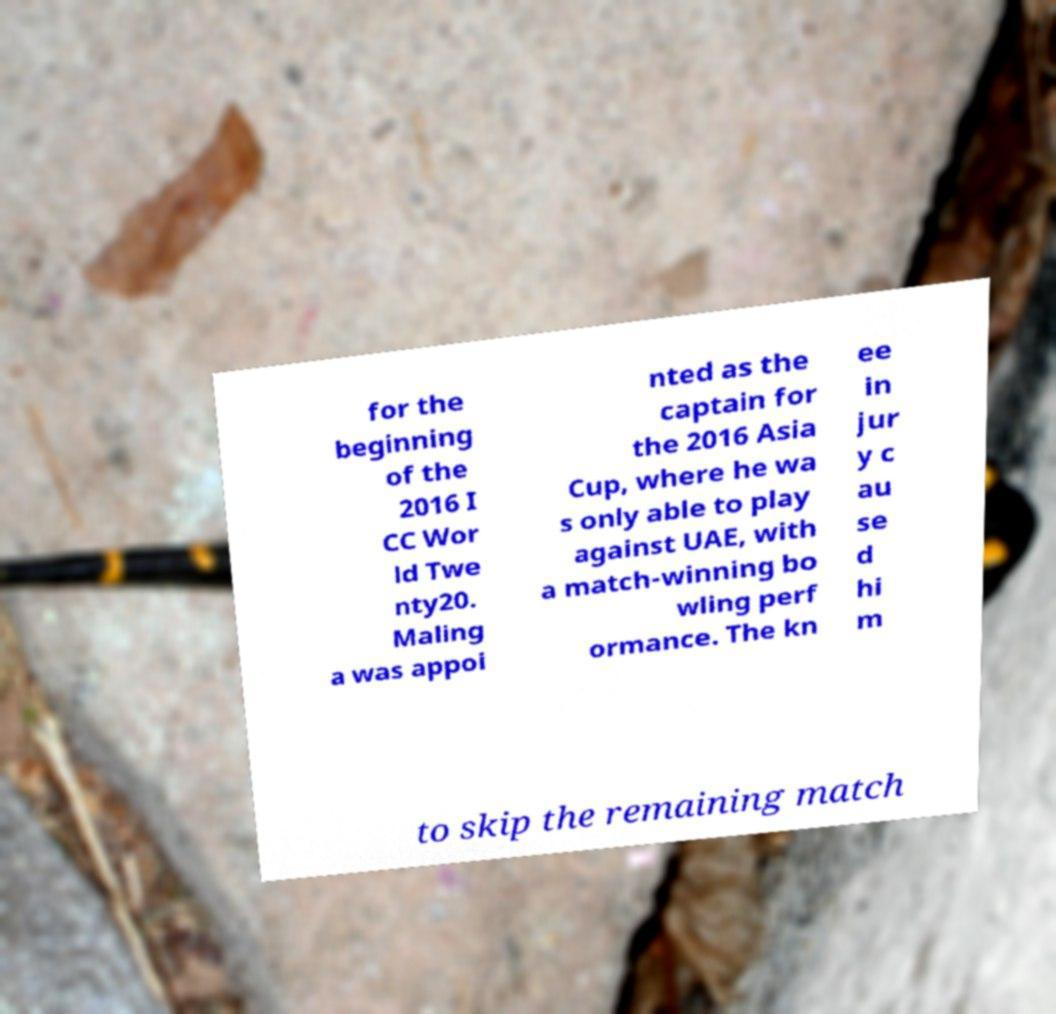Can you accurately transcribe the text from the provided image for me? for the beginning of the 2016 I CC Wor ld Twe nty20. Maling a was appoi nted as the captain for the 2016 Asia Cup, where he wa s only able to play against UAE, with a match-winning bo wling perf ormance. The kn ee in jur y c au se d hi m to skip the remaining match 